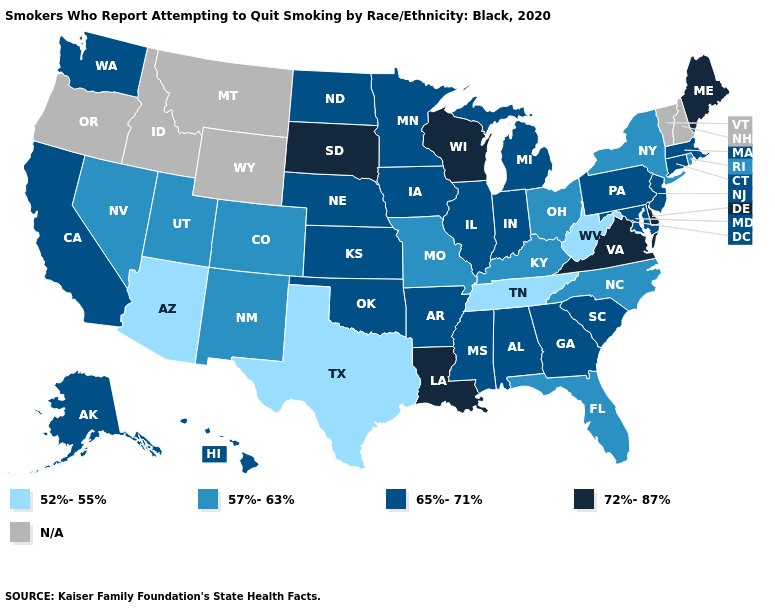What is the value of Kansas?
Answer briefly. 65%-71%. What is the lowest value in the USA?
Keep it brief. 52%-55%. What is the value of New Mexico?
Write a very short answer. 57%-63%. What is the lowest value in the West?
Give a very brief answer. 52%-55%. Does Ohio have the lowest value in the MidWest?
Be succinct. Yes. What is the value of Nebraska?
Write a very short answer. 65%-71%. What is the value of Georgia?
Give a very brief answer. 65%-71%. What is the highest value in the USA?
Answer briefly. 72%-87%. What is the value of New Jersey?
Give a very brief answer. 65%-71%. Among the states that border Utah , does Arizona have the highest value?
Answer briefly. No. Which states have the lowest value in the MidWest?
Concise answer only. Missouri, Ohio. What is the lowest value in the West?
Concise answer only. 52%-55%. What is the highest value in states that border Nebraska?
Keep it brief. 72%-87%. Among the states that border Ohio , which have the highest value?
Short answer required. Indiana, Michigan, Pennsylvania. What is the highest value in the USA?
Short answer required. 72%-87%. 